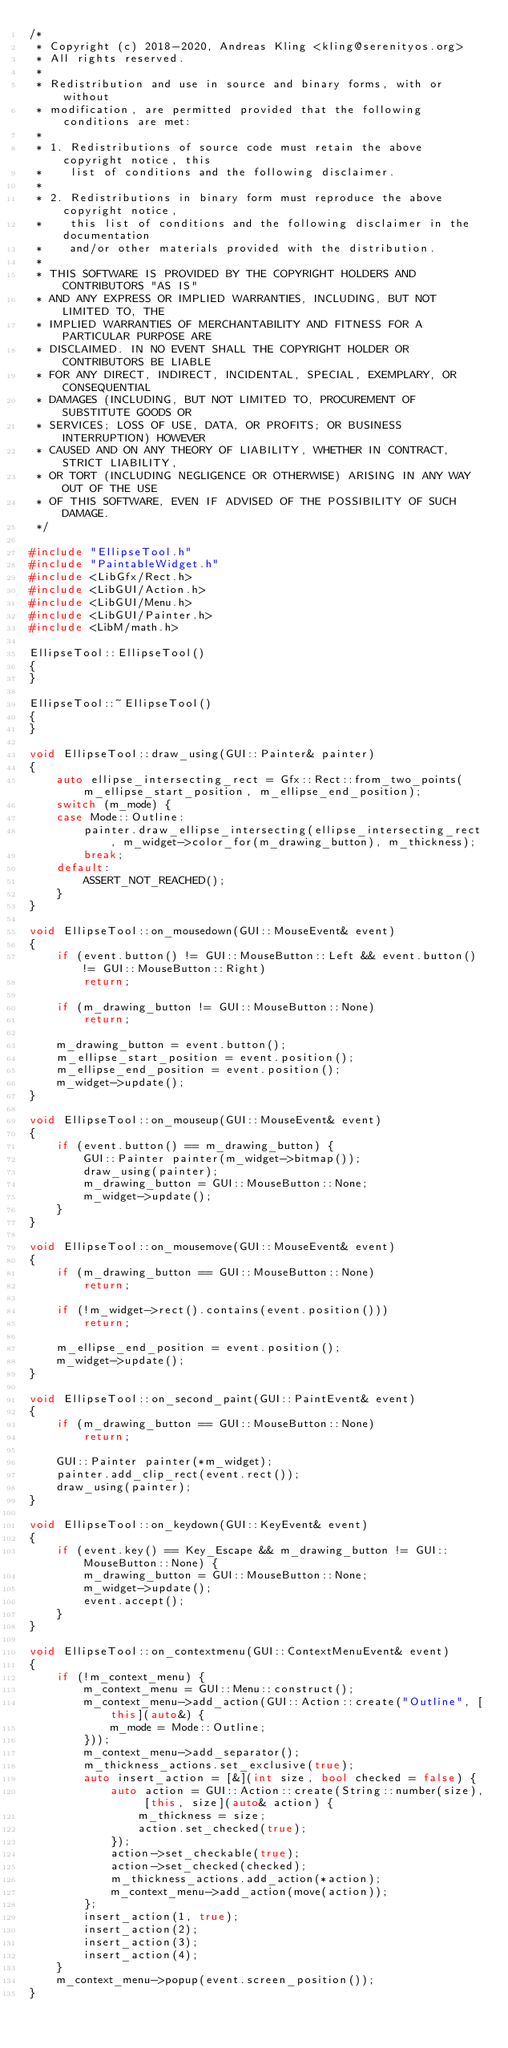<code> <loc_0><loc_0><loc_500><loc_500><_C++_>/*
 * Copyright (c) 2018-2020, Andreas Kling <kling@serenityos.org>
 * All rights reserved.
 *
 * Redistribution and use in source and binary forms, with or without
 * modification, are permitted provided that the following conditions are met:
 *
 * 1. Redistributions of source code must retain the above copyright notice, this
 *    list of conditions and the following disclaimer.
 *
 * 2. Redistributions in binary form must reproduce the above copyright notice,
 *    this list of conditions and the following disclaimer in the documentation
 *    and/or other materials provided with the distribution.
 *
 * THIS SOFTWARE IS PROVIDED BY THE COPYRIGHT HOLDERS AND CONTRIBUTORS "AS IS"
 * AND ANY EXPRESS OR IMPLIED WARRANTIES, INCLUDING, BUT NOT LIMITED TO, THE
 * IMPLIED WARRANTIES OF MERCHANTABILITY AND FITNESS FOR A PARTICULAR PURPOSE ARE
 * DISCLAIMED. IN NO EVENT SHALL THE COPYRIGHT HOLDER OR CONTRIBUTORS BE LIABLE
 * FOR ANY DIRECT, INDIRECT, INCIDENTAL, SPECIAL, EXEMPLARY, OR CONSEQUENTIAL
 * DAMAGES (INCLUDING, BUT NOT LIMITED TO, PROCUREMENT OF SUBSTITUTE GOODS OR
 * SERVICES; LOSS OF USE, DATA, OR PROFITS; OR BUSINESS INTERRUPTION) HOWEVER
 * CAUSED AND ON ANY THEORY OF LIABILITY, WHETHER IN CONTRACT, STRICT LIABILITY,
 * OR TORT (INCLUDING NEGLIGENCE OR OTHERWISE) ARISING IN ANY WAY OUT OF THE USE
 * OF THIS SOFTWARE, EVEN IF ADVISED OF THE POSSIBILITY OF SUCH DAMAGE.
 */

#include "EllipseTool.h"
#include "PaintableWidget.h"
#include <LibGfx/Rect.h>
#include <LibGUI/Action.h>
#include <LibGUI/Menu.h>
#include <LibGUI/Painter.h>
#include <LibM/math.h>

EllipseTool::EllipseTool()
{
}

EllipseTool::~EllipseTool()
{
}

void EllipseTool::draw_using(GUI::Painter& painter)
{
    auto ellipse_intersecting_rect = Gfx::Rect::from_two_points(m_ellipse_start_position, m_ellipse_end_position);
    switch (m_mode) {
    case Mode::Outline:
        painter.draw_ellipse_intersecting(ellipse_intersecting_rect, m_widget->color_for(m_drawing_button), m_thickness);
        break;
    default:
        ASSERT_NOT_REACHED();
    }
}

void EllipseTool::on_mousedown(GUI::MouseEvent& event)
{
    if (event.button() != GUI::MouseButton::Left && event.button() != GUI::MouseButton::Right)
        return;

    if (m_drawing_button != GUI::MouseButton::None)
        return;

    m_drawing_button = event.button();
    m_ellipse_start_position = event.position();
    m_ellipse_end_position = event.position();
    m_widget->update();
}

void EllipseTool::on_mouseup(GUI::MouseEvent& event)
{
    if (event.button() == m_drawing_button) {
        GUI::Painter painter(m_widget->bitmap());
        draw_using(painter);
        m_drawing_button = GUI::MouseButton::None;
        m_widget->update();
    }
}

void EllipseTool::on_mousemove(GUI::MouseEvent& event)
{
    if (m_drawing_button == GUI::MouseButton::None)
        return;

    if (!m_widget->rect().contains(event.position()))
        return;

    m_ellipse_end_position = event.position();
    m_widget->update();
}

void EllipseTool::on_second_paint(GUI::PaintEvent& event)
{
    if (m_drawing_button == GUI::MouseButton::None)
        return;

    GUI::Painter painter(*m_widget);
    painter.add_clip_rect(event.rect());
    draw_using(painter);
}

void EllipseTool::on_keydown(GUI::KeyEvent& event)
{
    if (event.key() == Key_Escape && m_drawing_button != GUI::MouseButton::None) {
        m_drawing_button = GUI::MouseButton::None;
        m_widget->update();
        event.accept();
    }
}

void EllipseTool::on_contextmenu(GUI::ContextMenuEvent& event)
{
    if (!m_context_menu) {
        m_context_menu = GUI::Menu::construct();
        m_context_menu->add_action(GUI::Action::create("Outline", [this](auto&) {
            m_mode = Mode::Outline;
        }));
        m_context_menu->add_separator();
        m_thickness_actions.set_exclusive(true);
        auto insert_action = [&](int size, bool checked = false) {
            auto action = GUI::Action::create(String::number(size), [this, size](auto& action) {
                m_thickness = size;
                action.set_checked(true);
            });
            action->set_checkable(true);
            action->set_checked(checked);
            m_thickness_actions.add_action(*action);
            m_context_menu->add_action(move(action));
        };
        insert_action(1, true);
        insert_action(2);
        insert_action(3);
        insert_action(4);
    }
    m_context_menu->popup(event.screen_position());
}
</code> 